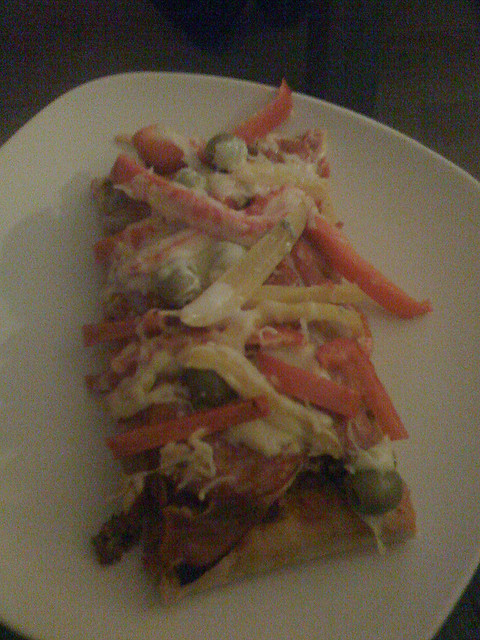<image>What pork product can you identify? I am not sure what pork product can be identified. It could be bacon, pepperoni, or ham. What pork product can you identify? I am not sure what pork product can be identified. It could be bacon, pepperoni, or ham. 